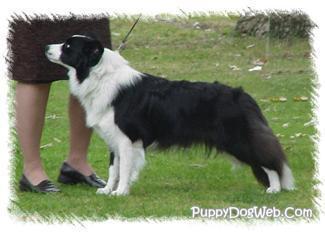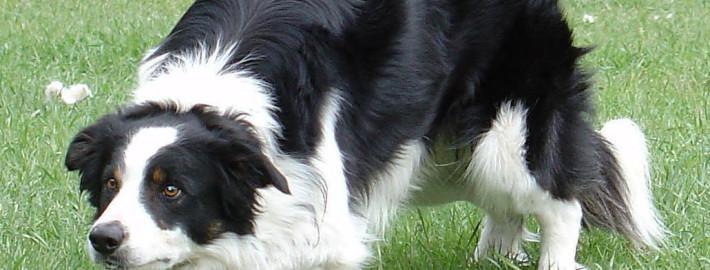The first image is the image on the left, the second image is the image on the right. Examine the images to the left and right. Is the description "One of the images shows exactly two dogs." accurate? Answer yes or no. No. The first image is the image on the left, the second image is the image on the right. Evaluate the accuracy of this statement regarding the images: "An image shows a standing dog in profile facing right.". Is it true? Answer yes or no. No. 